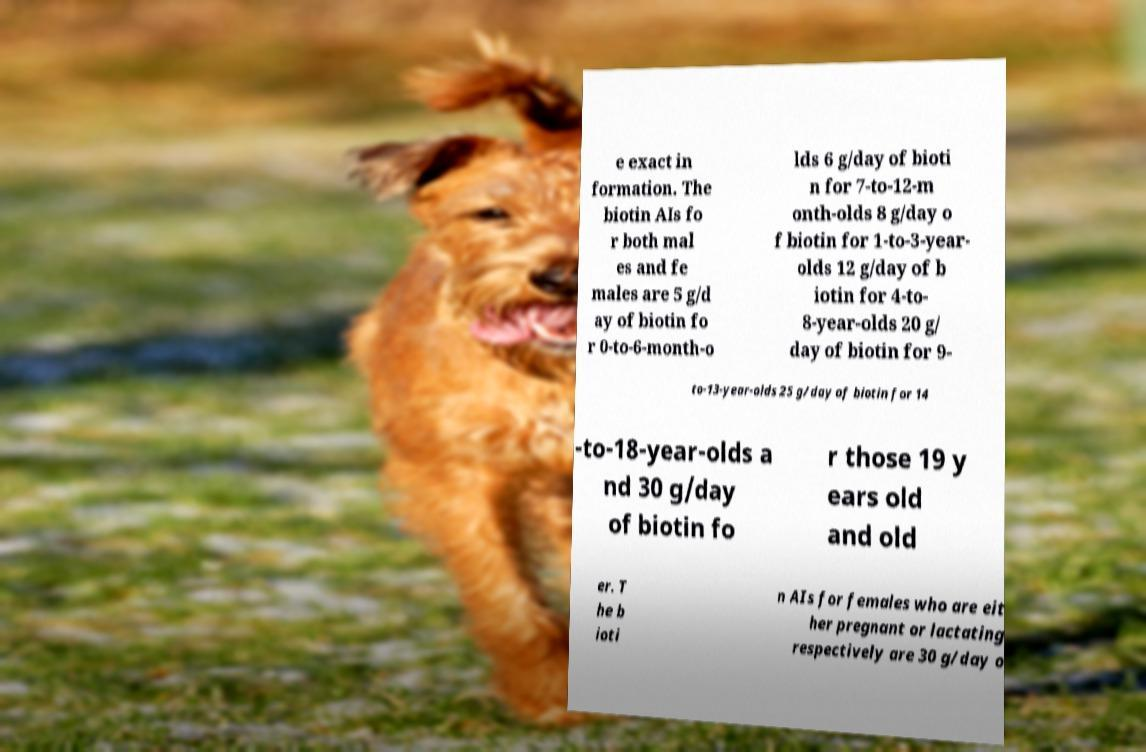I need the written content from this picture converted into text. Can you do that? e exact in formation. The biotin AIs fo r both mal es and fe males are 5 g/d ay of biotin fo r 0-to-6-month-o lds 6 g/day of bioti n for 7-to-12-m onth-olds 8 g/day o f biotin for 1-to-3-year- olds 12 g/day of b iotin for 4-to- 8-year-olds 20 g/ day of biotin for 9- to-13-year-olds 25 g/day of biotin for 14 -to-18-year-olds a nd 30 g/day of biotin fo r those 19 y ears old and old er. T he b ioti n AIs for females who are eit her pregnant or lactating respectively are 30 g/day o 